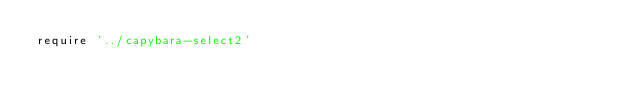Convert code to text. <code><loc_0><loc_0><loc_500><loc_500><_Ruby_>require '../capybara-select2'</code> 